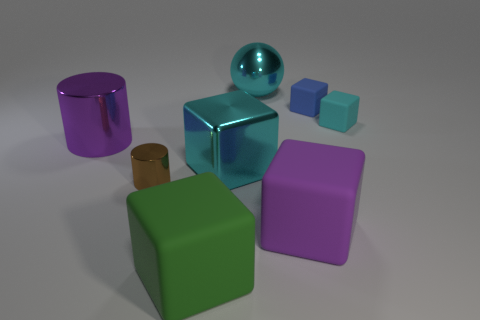There is a rubber thing on the left side of the big ball; is it the same color as the metallic ball? The object on the left side of the large sphere is indeed a rubber item. However, while both it and the metallic sphere share a similar vibrancy, they are not the same color. The rubber object has a purple hue, whereas the metallic sphere is more of a cyan or light blue color, reflecting light differently due to its metallic properties. 